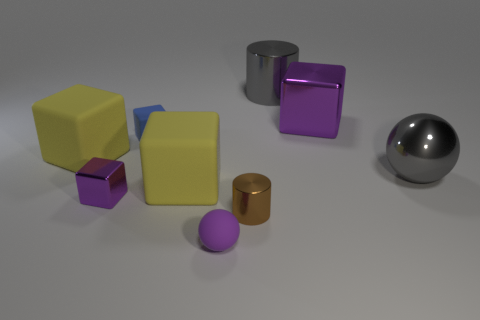Subtract all blue cubes. How many cubes are left? 4 Subtract all green blocks. Subtract all brown spheres. How many blocks are left? 5 Subtract all cylinders. How many objects are left? 7 Subtract all large yellow cubes. Subtract all purple blocks. How many objects are left? 5 Add 8 tiny matte cubes. How many tiny matte cubes are left? 9 Add 7 blue shiny blocks. How many blue shiny blocks exist? 7 Subtract 0 red balls. How many objects are left? 9 